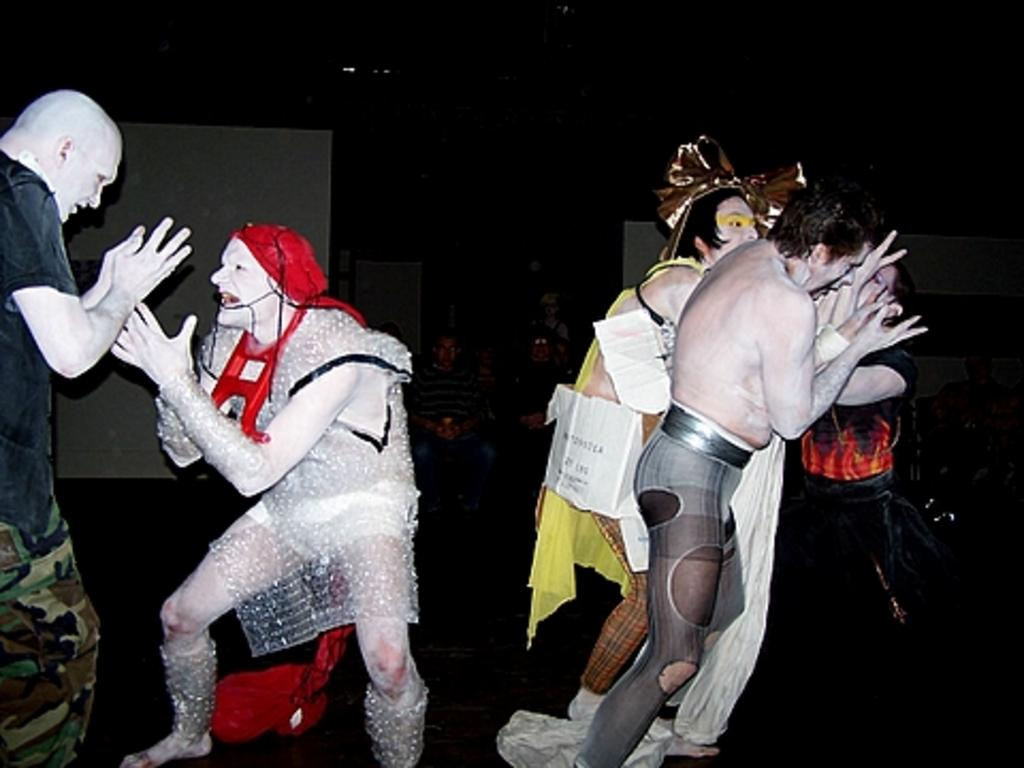What is happening in the image? There is a group of people standing in the image. What are the people wearing? The people are wearing fancy dresses. Are there any people sitting in the image? Yes, there are people sitting in the image. How would you describe the lighting in the image? The background of the image appears dark. How many crows can be seen in the image? There are no crows present in the image. What achievements have the people in the image accomplished? The provided facts do not mention any specific achievements of the people in the image. 